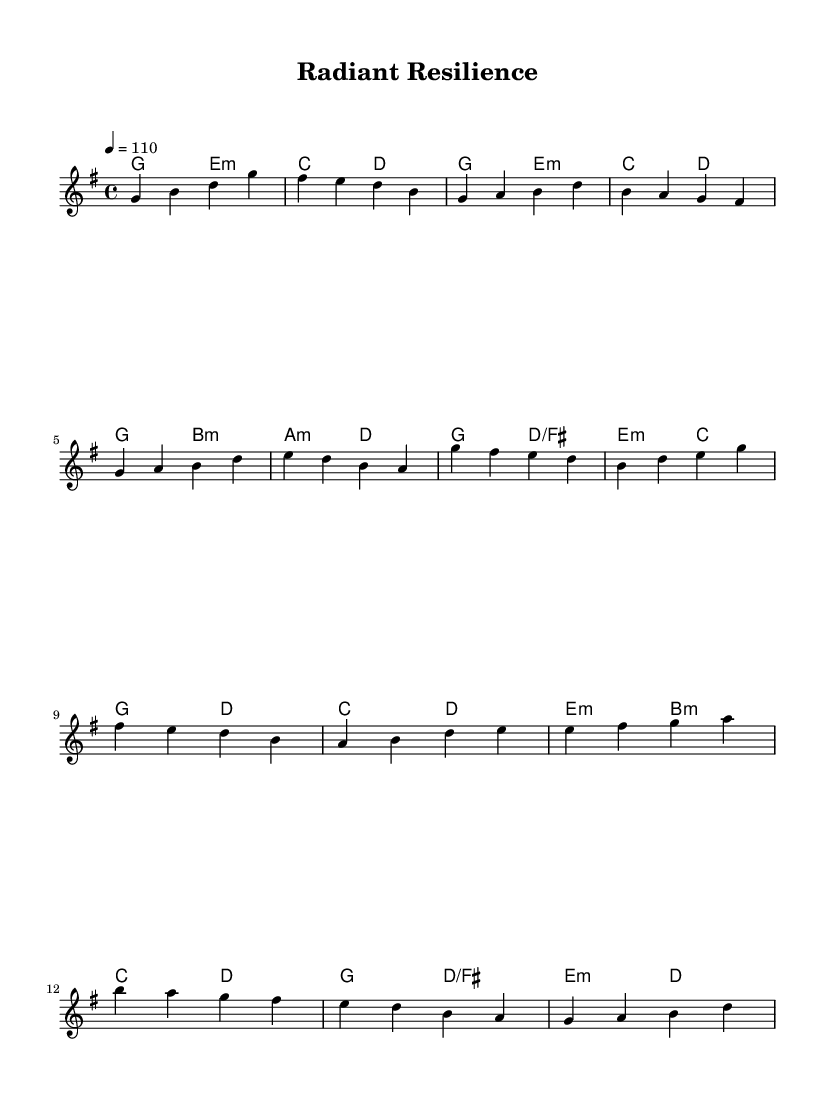What is the key signature of this music? The key signature is G major, which has one sharp (F#). This is indicated in the global settings of the sheet music.
Answer: G major What is the time signature of this music? The time signature is 4/4, as specified in the global settings. This means there are four beats in each measure.
Answer: 4/4 What is the tempo marking of this music? The tempo marking is 110 beats per minute, indicated by “4 = 110” in the global settings. This tells the performer how fast to play the piece.
Answer: 110 How many measures are in the chorus section? The chorus section has four measures, as observed when counting the measures of melody and harmonies labeled for that section.
Answer: 4 In which section does the melody first ascend to a high note? The melody first ascends to a high note in the chorus section when it reaches the high G note. This can be identified in the melody line during that section.
Answer: Chorus What chords are used in the introduction? The chords in the introduction are G major, E minor, C major, and D major, specified in the harmonies section for that part of the music.
Answer: G, E minor, C, D How does the bridge differ from the verse in terms of emotional tone? The bridge progresses the emotional tone by introducing a B minor chord, which provides a contrast to the verse that primarily uses G major and E minor. This shift can be perceived as more uplifting.
Answer: More uplifting 